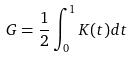<formula> <loc_0><loc_0><loc_500><loc_500>G = \frac { 1 } { 2 } \int _ { 0 } ^ { 1 } K ( t ) d t</formula> 